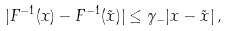<formula> <loc_0><loc_0><loc_500><loc_500>| { F } ^ { - 1 } ( { x } ) - { F } ^ { - 1 } ( \tilde { x } ) | \leq \gamma _ { - } | { x } - \tilde { x } | \, ,</formula> 